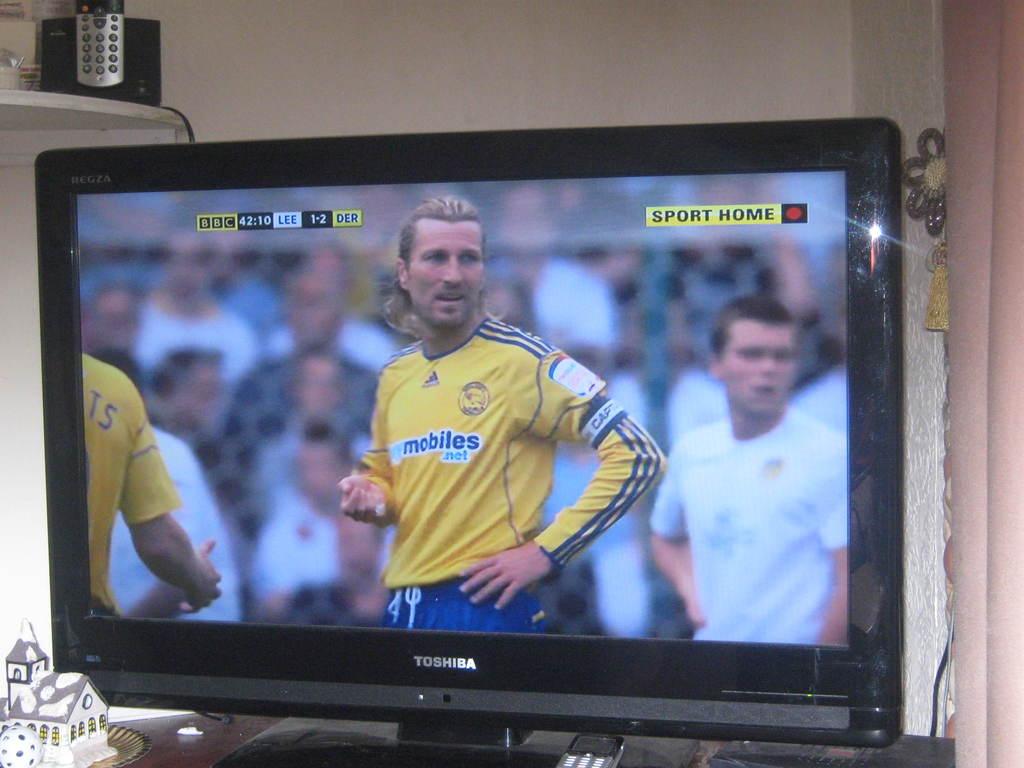What is the advertisement on the athlete's jersey?
Make the answer very short. Mobiles.net. Where does the red button take you?
Offer a terse response. Sport home. 